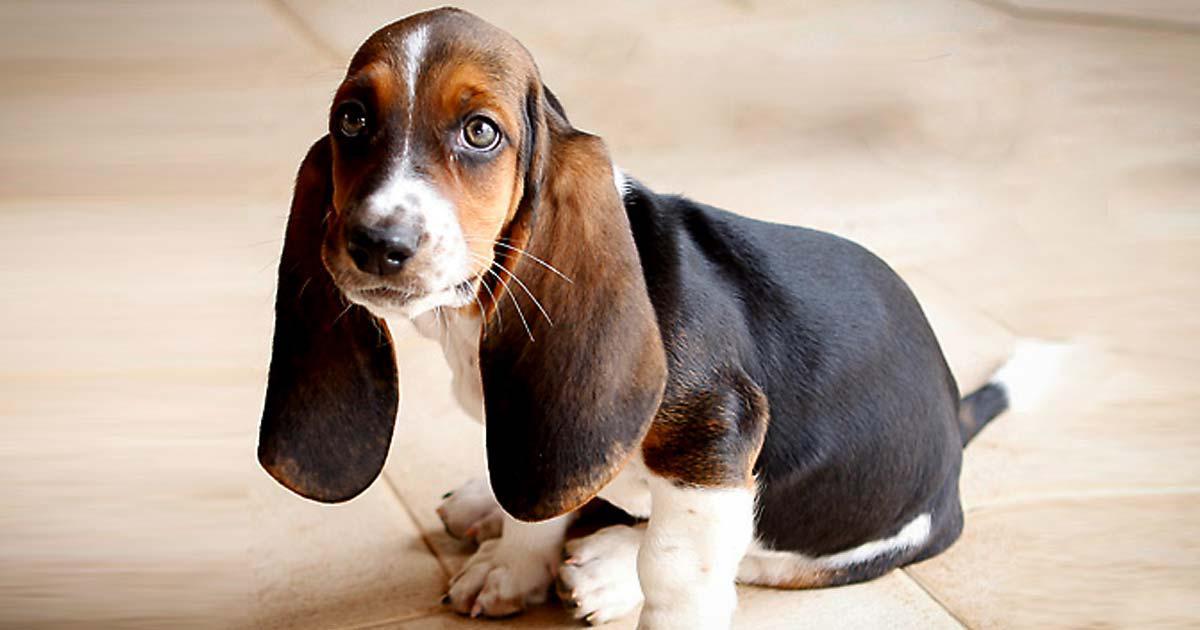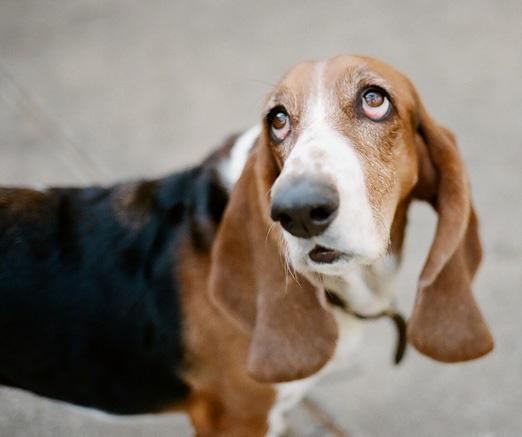The first image is the image on the left, the second image is the image on the right. Examine the images to the left and right. Is the description "there is a dog lying on the ground" accurate? Answer yes or no. No. 